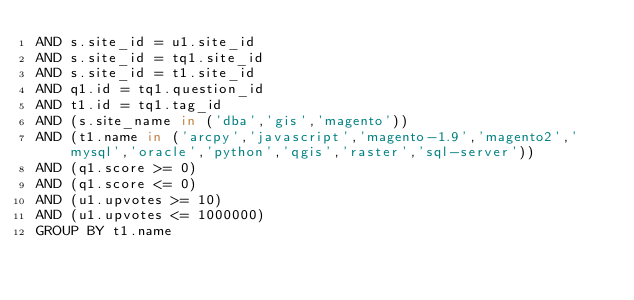Convert code to text. <code><loc_0><loc_0><loc_500><loc_500><_SQL_>AND s.site_id = u1.site_id
AND s.site_id = tq1.site_id
AND s.site_id = t1.site_id
AND q1.id = tq1.question_id
AND t1.id = tq1.tag_id
AND (s.site_name in ('dba','gis','magento'))
AND (t1.name in ('arcpy','javascript','magento-1.9','magento2','mysql','oracle','python','qgis','raster','sql-server'))
AND (q1.score >= 0)
AND (q1.score <= 0)
AND (u1.upvotes >= 10)
AND (u1.upvotes <= 1000000)
GROUP BY t1.name</code> 